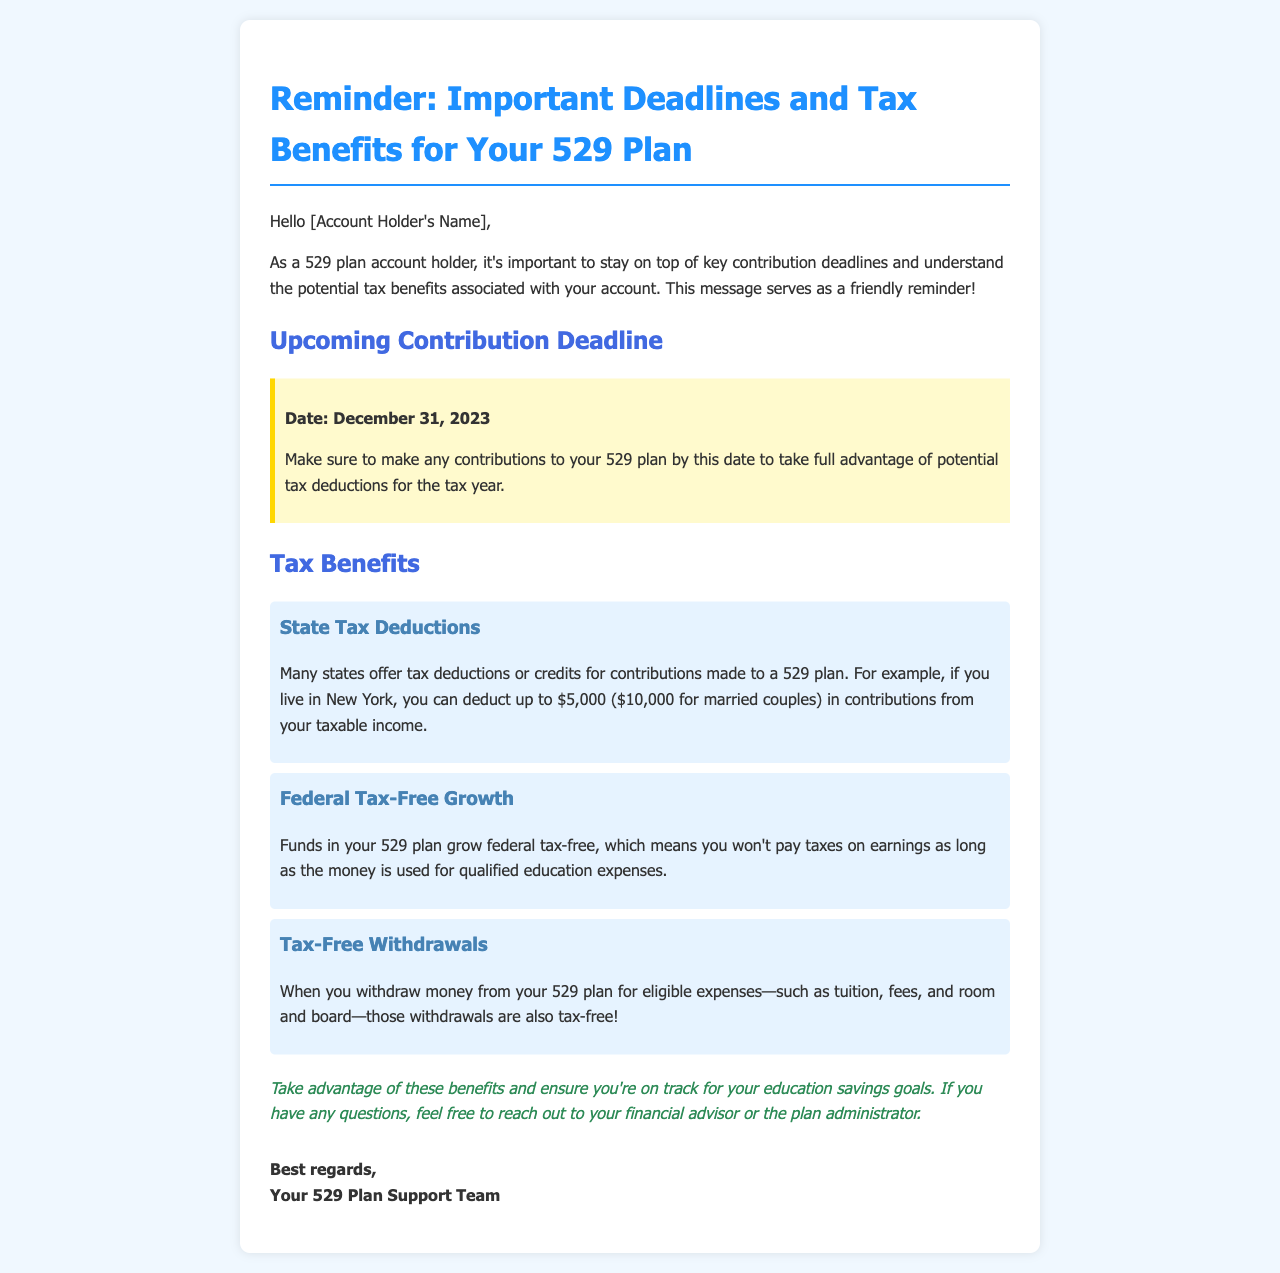What is the contribution deadline? The document specifies that the contribution deadline is December 31, 2023.
Answer: December 31, 2023 What can you deduct from your taxable income in New York? According to the document, you can deduct up to $5,000 ($10,000 for married couples) in contributions from your taxable income in New York.
Answer: $5,000 ($10,000 for married couples) What is one benefit of 529 plan earnings? The document states that funds in your 529 plan grow federal tax-free as long as they are used for qualified education expenses.
Answer: Federal tax-free growth What types of expenses are withdrawals from a 529 plan tax-free? The document mentions that withdrawals for eligible expenses, such as tuition, fees, and room and board, are tax-free.
Answer: Tuition, fees, and room and board Who can you contact with questions about your 529 plan? The document suggests reaching out to your financial advisor or the plan administrator for any questions.
Answer: Financial advisor or plan administrator 